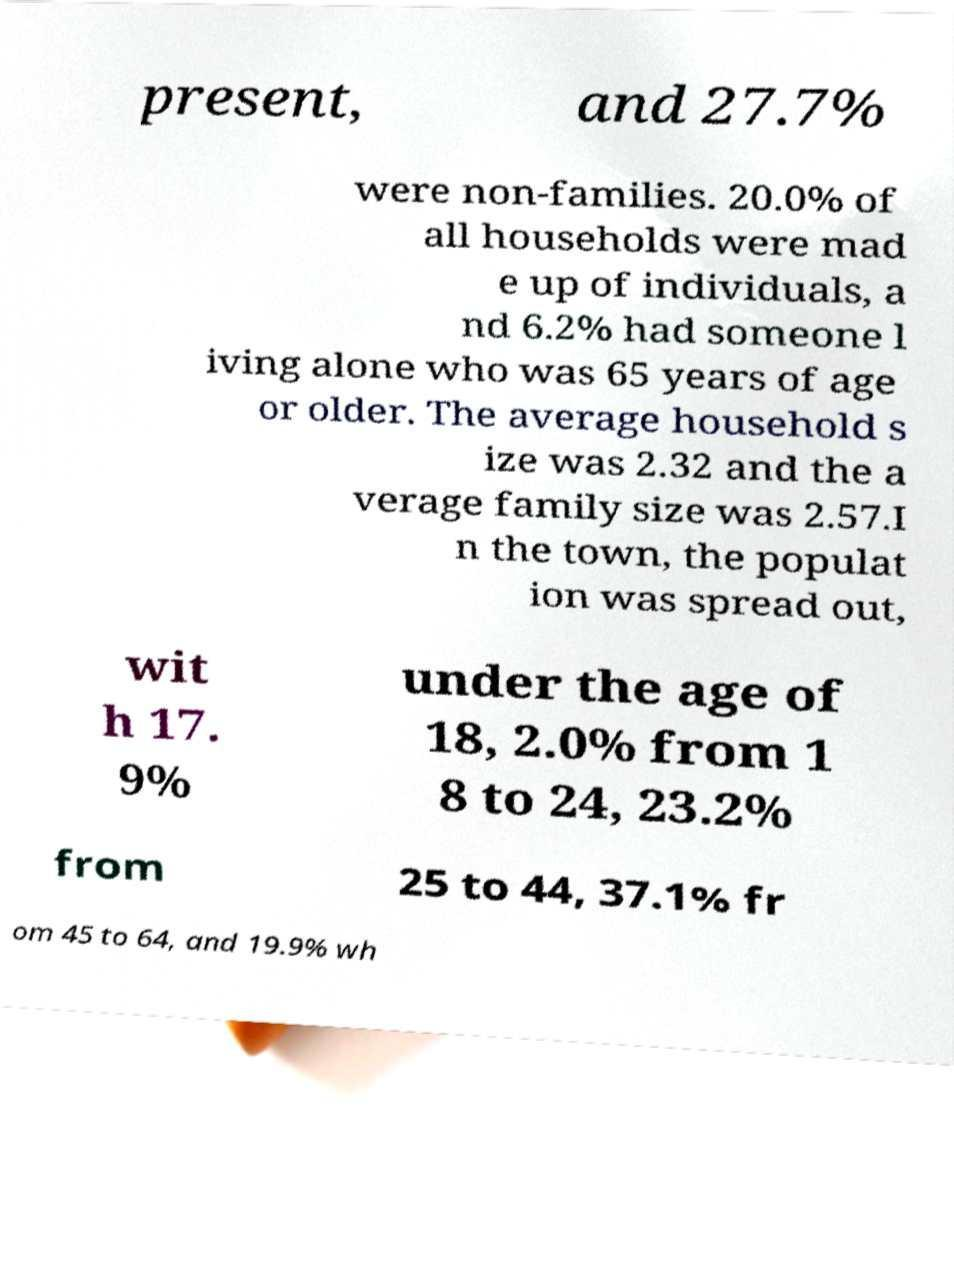I need the written content from this picture converted into text. Can you do that? present, and 27.7% were non-families. 20.0% of all households were mad e up of individuals, a nd 6.2% had someone l iving alone who was 65 years of age or older. The average household s ize was 2.32 and the a verage family size was 2.57.I n the town, the populat ion was spread out, wit h 17. 9% under the age of 18, 2.0% from 1 8 to 24, 23.2% from 25 to 44, 37.1% fr om 45 to 64, and 19.9% wh 